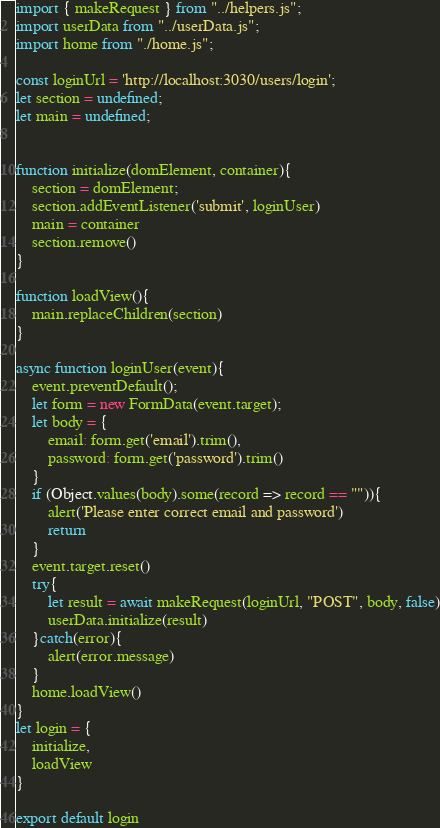<code> <loc_0><loc_0><loc_500><loc_500><_JavaScript_>import { makeRequest } from "../helpers.js";
import userData from "../userData.js";
import home from "./home.js";

const loginUrl = 'http://localhost:3030/users/login';
let section = undefined;
let main = undefined;


function initialize(domElement, container){
    section = domElement;
    section.addEventListener('submit', loginUser)
    main = container 
    section.remove()
}

function loadView(){
    main.replaceChildren(section)
}

async function loginUser(event){
    event.preventDefault();
    let form = new FormData(event.target);
    let body = {
        email: form.get('email').trim(),
        password: form.get('password').trim()
    }
    if (Object.values(body).some(record => record == "")){
        alert('Please enter correct email and password')
        return
    }
    event.target.reset()
    try{
        let result = await makeRequest(loginUrl, "POST", body, false)
        userData.initialize(result)
    }catch(error){
        alert(error.message)
    }
    home.loadView()
}
let login = {
    initialize, 
    loadView
}

export default login</code> 